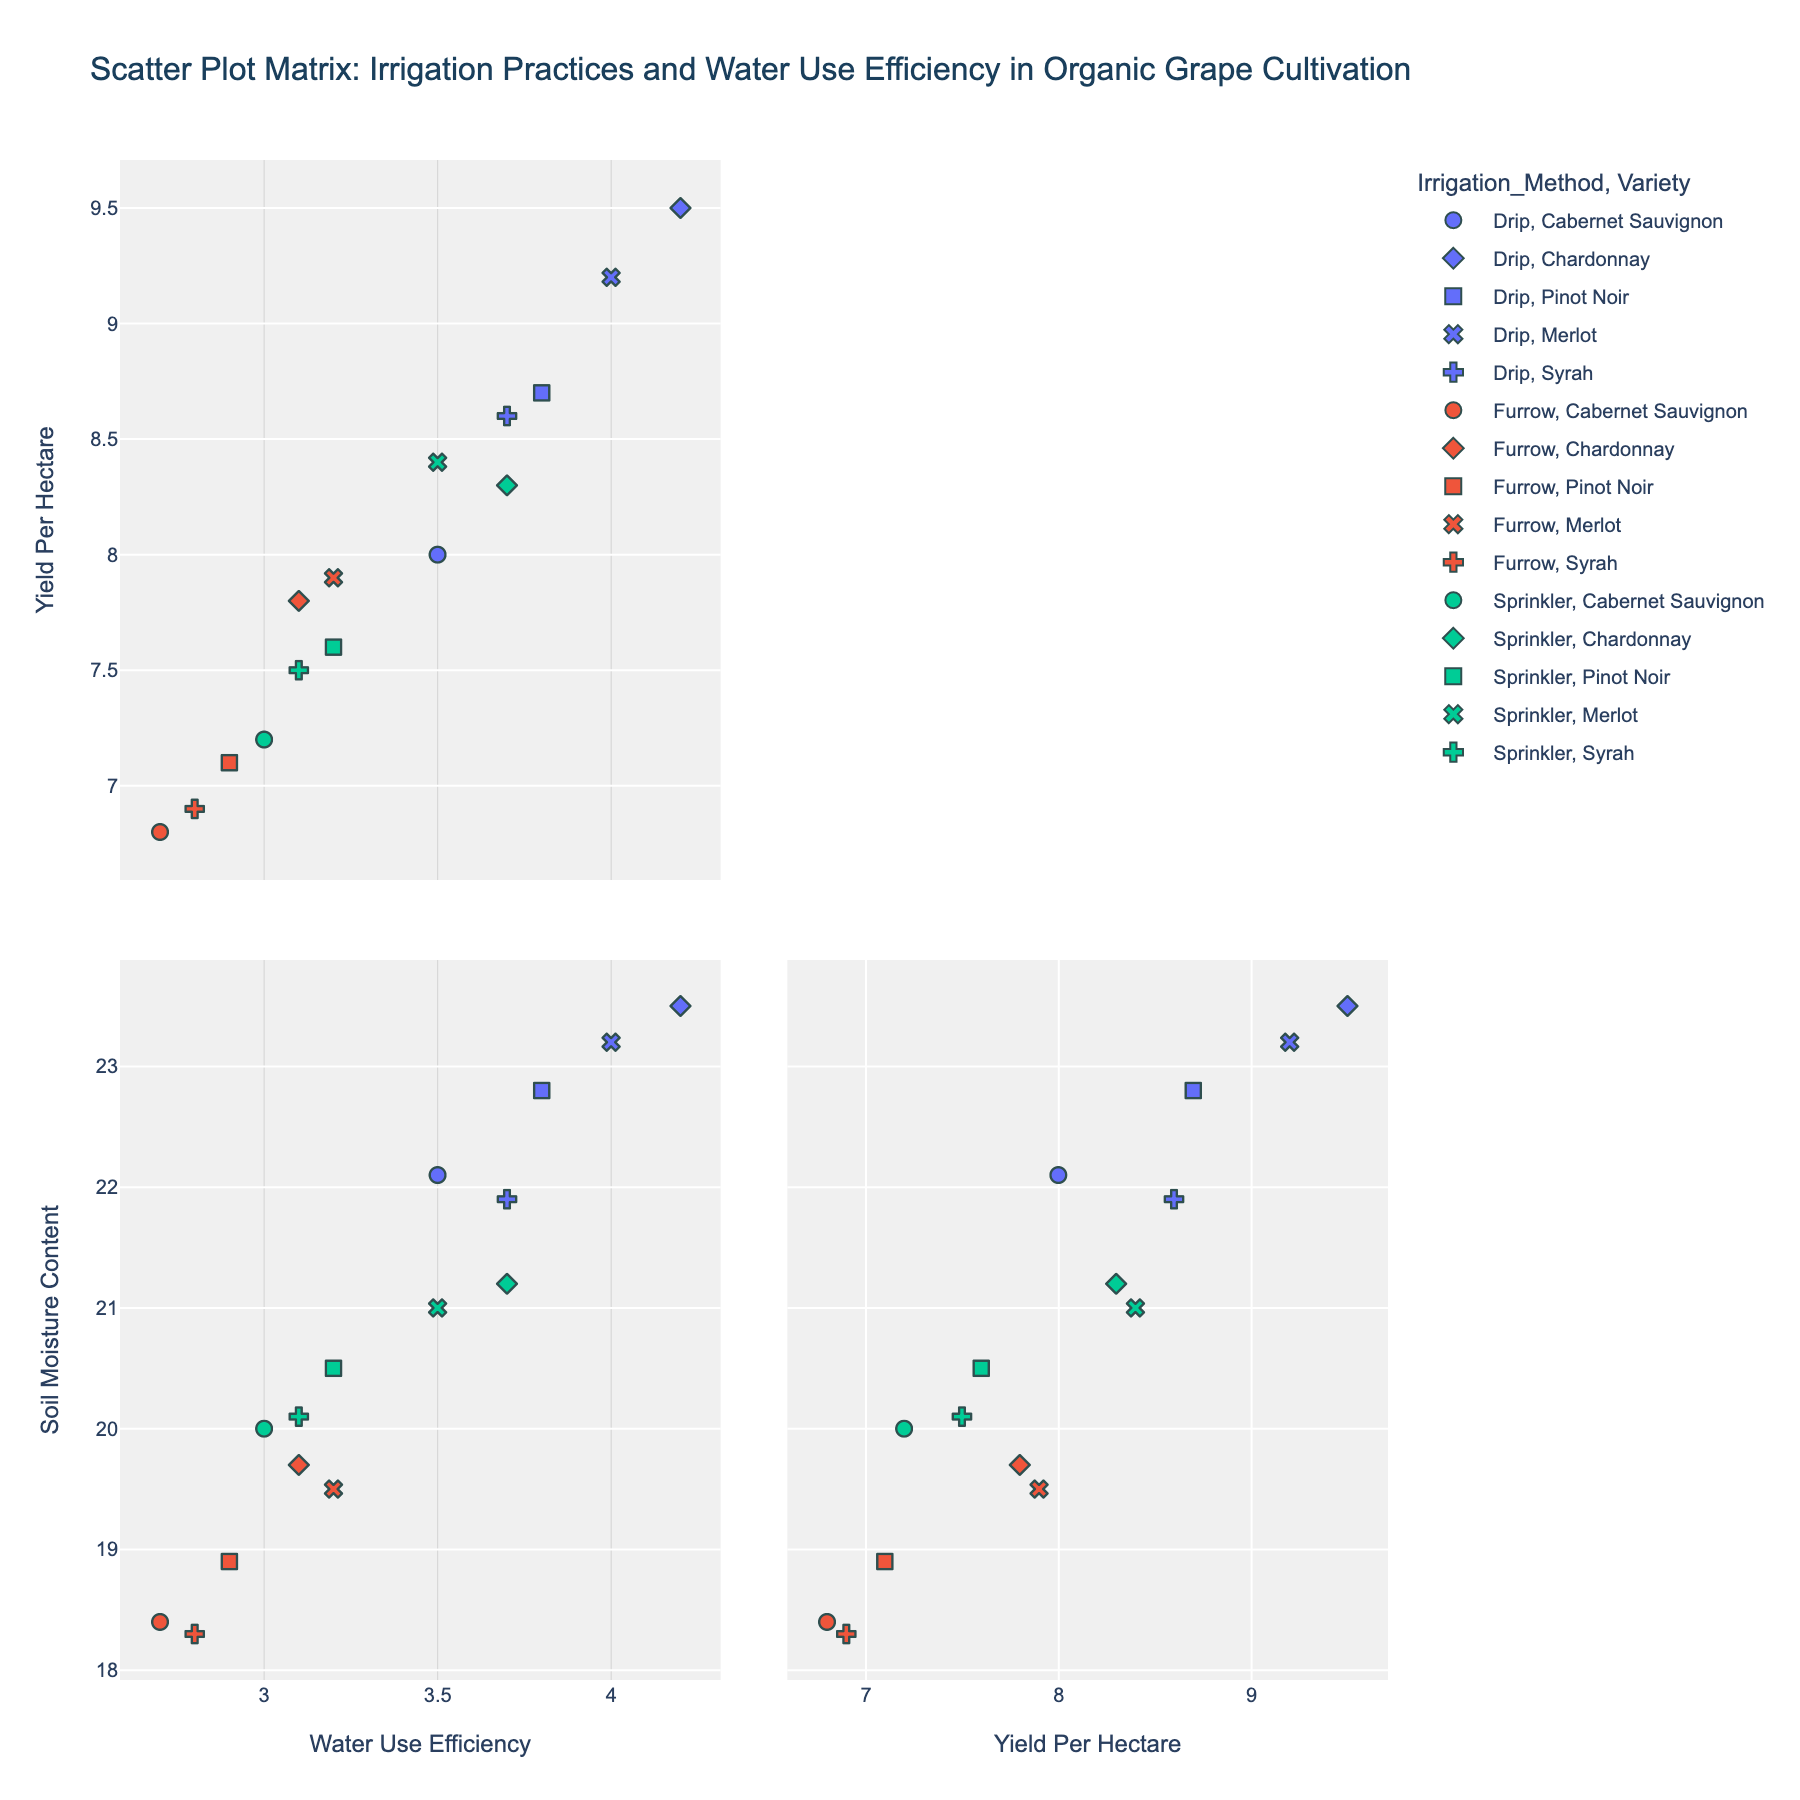What is the title of the scatter plot matrix? The title is at the top center of the figure. The title for this scatter plot matrix is given as 'Scatter Plot Matrix: Irrigation Practices and Water Use Efficiency in Organic Grape Cultivation'.
Answer: Scatter Plot Matrix: Irrigation Practices and Water Use Efficiency in Organic Grape Cultivation How many dimensions are represented in the scatter plot matrix? The scatter plot matrix includes dimensions shared in the figure. It shows scatter plots of 'Water Use Efficiency', 'Yield Per Hectare', and 'Soil Moisture Content'.
Answer: Three dimensions Which irrigation method has the highest water use efficiency? Within the scatter plots involving 'Water Use Efficiency', identify the highest value, then observe the corresponding irrigation method by color coding. Drip irrigation method has the highest water use efficiency values.
Answer: Drip What is the general relationship between yield per hectare and soil moisture content for furrow irrigation? Look for plots showing 'Yield Per Hectare' on one axis and 'Soil Moisture Content' on the other, and then examine the scatter points specific to furrow irrigation (color coded). Furrow irrigation shows a positive relationship between 'Yield Per Hectare' and 'Soil Moisture Content'.
Answer: Positive relationship Compare the water use efficiency between Drip and Sprinkler irrigation methods. Which one is generally better? Identify plots involving 'Water Use Efficiency' and compare the spread and clustering of values for Drip and Sprinkler irrigation methods. Drip irrigation generally shows higher water use efficiency compared to Sprinkler irrigation.
Answer: Drip Which grape variety and irrigation method combination seems to achieve the highest yield per hectare? Find the scatter plot dimensions involving 'Yield Per Hectare' and identify the highest values, then check the corresponding grape varieties and irrigation method. Chardonnay with Drip irrigation achieves the highest yield per hectare.
Answer: Chardonnay with Drip How does soil moisture content vary with different irrigation methods? Examine the scatter plots involving 'Soil Moisture Content' and see how values differ for Drip, Furrow, and Sprinkler. Drip irrigation generally shows higher soil moisture content compared to Furrow and Sprinkler.
Answer: Drip generally highest Which grape variety is consistently showing lower water use efficiency across different irrigation methods? Review all scatter plots involving 'Water Use Efficiency' and look at the distribution of points for each grape variety, observing the trend across irrigation methods. Syrah consistently shows lower water use efficiency.
Answer: Syrah 